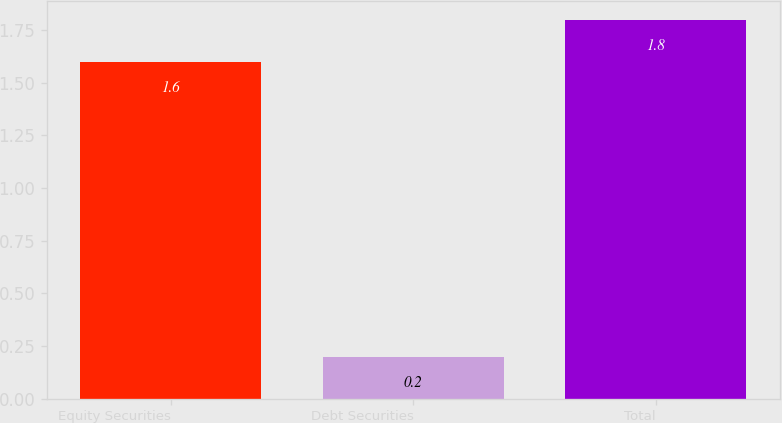Convert chart. <chart><loc_0><loc_0><loc_500><loc_500><bar_chart><fcel>Equity Securities<fcel>Debt Securities<fcel>Total<nl><fcel>1.6<fcel>0.2<fcel>1.8<nl></chart> 